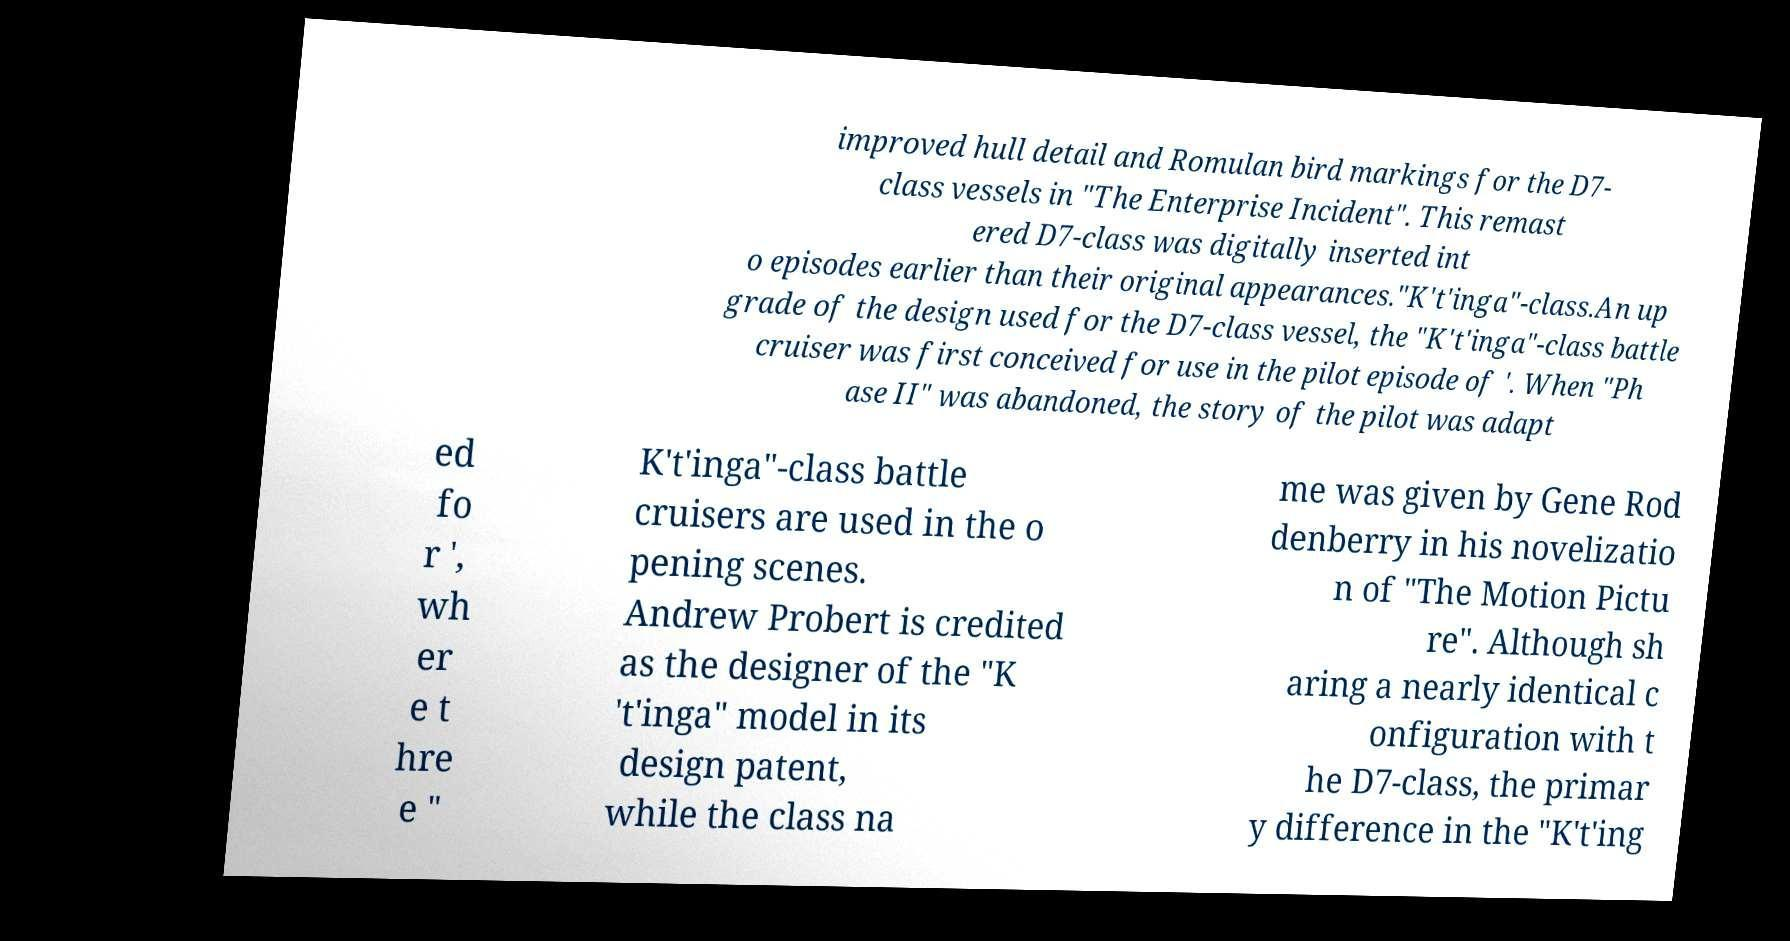Could you extract and type out the text from this image? improved hull detail and Romulan bird markings for the D7- class vessels in "The Enterprise Incident". This remast ered D7-class was digitally inserted int o episodes earlier than their original appearances."K't'inga"-class.An up grade of the design used for the D7-class vessel, the "K't'inga"-class battle cruiser was first conceived for use in the pilot episode of '. When "Ph ase II" was abandoned, the story of the pilot was adapt ed fo r ', wh er e t hre e " K't'inga"-class battle cruisers are used in the o pening scenes. Andrew Probert is credited as the designer of the "K 't'inga" model in its design patent, while the class na me was given by Gene Rod denberry in his novelizatio n of "The Motion Pictu re". Although sh aring a nearly identical c onfiguration with t he D7-class, the primar y difference in the "K't'ing 